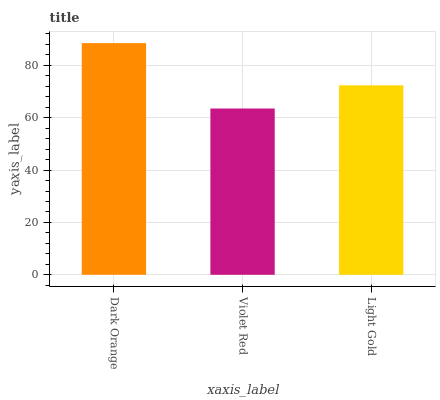Is Light Gold the minimum?
Answer yes or no. No. Is Light Gold the maximum?
Answer yes or no. No. Is Light Gold greater than Violet Red?
Answer yes or no. Yes. Is Violet Red less than Light Gold?
Answer yes or no. Yes. Is Violet Red greater than Light Gold?
Answer yes or no. No. Is Light Gold less than Violet Red?
Answer yes or no. No. Is Light Gold the high median?
Answer yes or no. Yes. Is Light Gold the low median?
Answer yes or no. Yes. Is Dark Orange the high median?
Answer yes or no. No. Is Violet Red the low median?
Answer yes or no. No. 